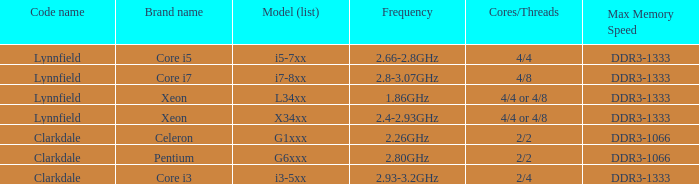What is the operating frequency of the pentium processor? 2.80GHz. 